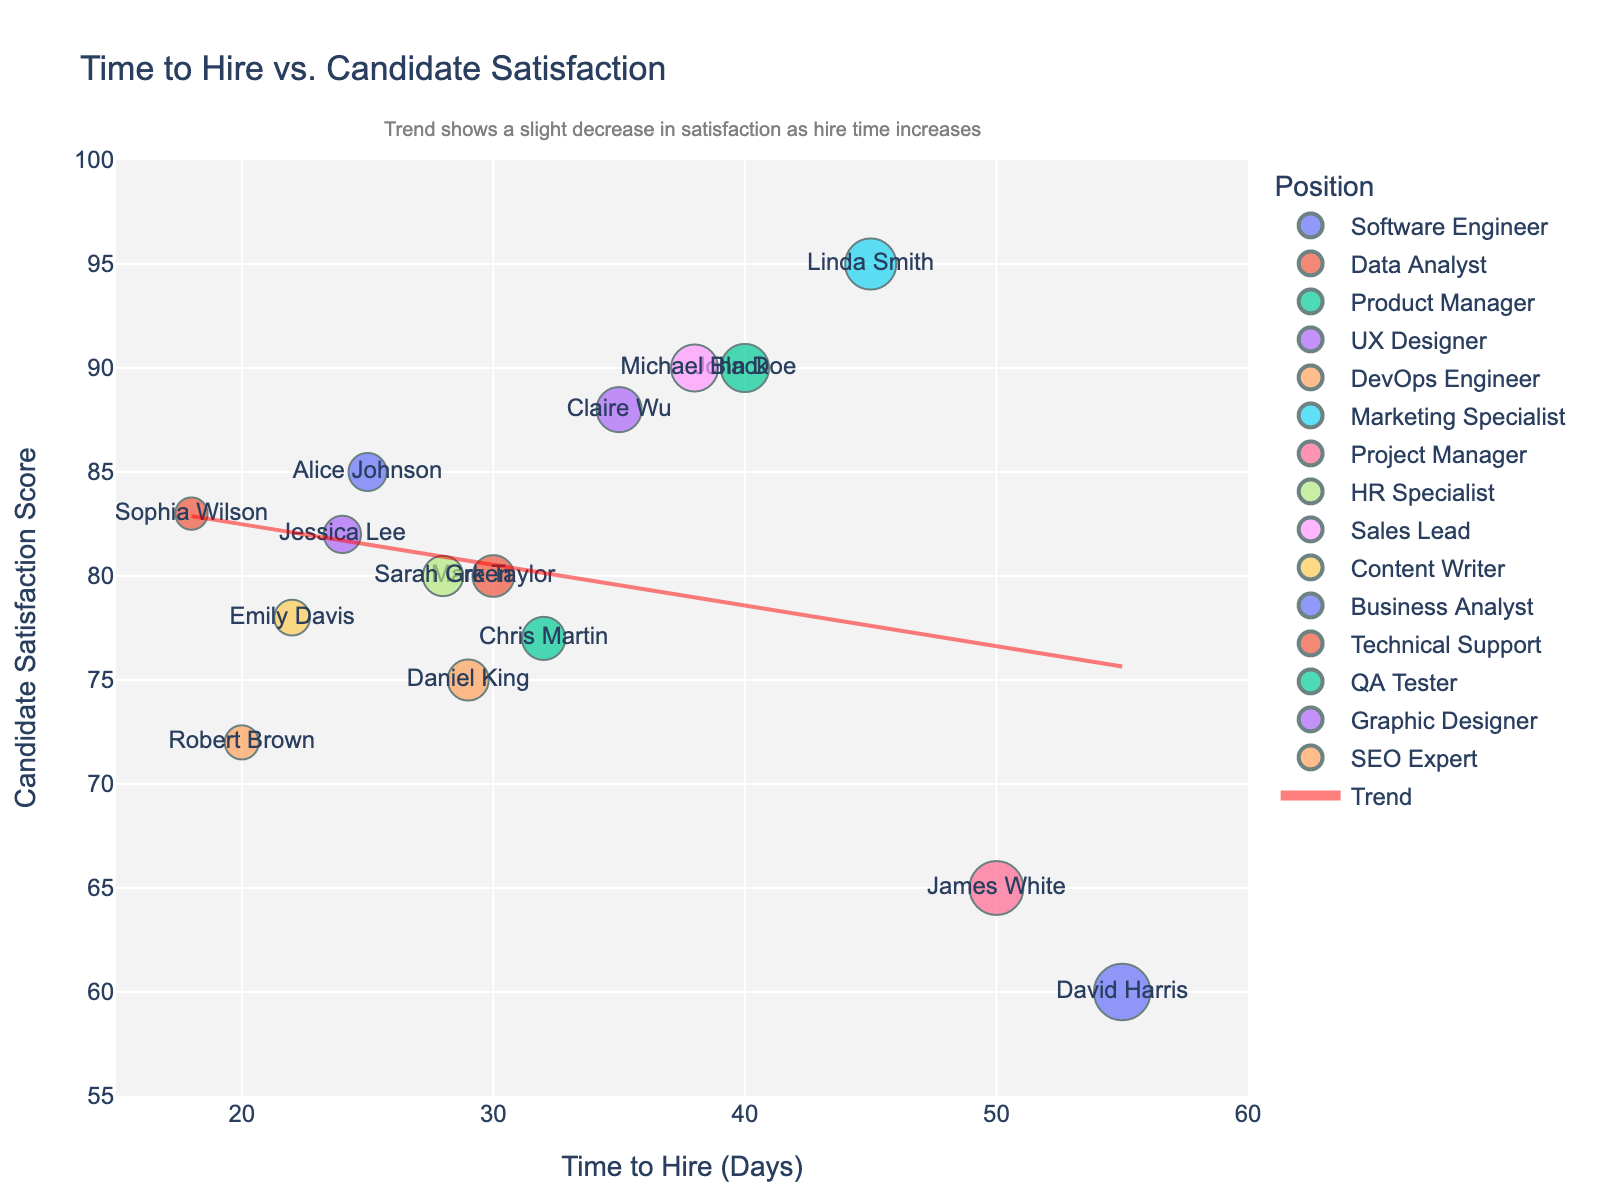How many data points are in the scatter plot? Count the number of different candidate names or dots on the scatter plot. There are 15 candidates.
Answer: 15 What are the ranges of the x-axis and y-axis? The x-axis represents 'Time to Hire (Days)' and ranges from 15 to 60 days, while the y-axis represents 'Candidate Satisfaction Score' and ranges from 55 to 100.
Answer: 15–60 for x, 55–100 for y What is the title of the scatter plot? The title is usually located at the top of the scatter plot. The title of this plot is 'Time to Hire vs. Candidate Satisfaction'.
Answer: Time to Hire vs. Candidate Satisfaction Which candidate has the highest satisfaction score and what is it? The highest data point on the y-axis represents the highest satisfaction score, which corresponds to Linda Smith. The score is 95.
Answer: Linda Smith, 95 How does the trend line behave as the time to hire increases? The trend line's direction shows the general behavior. In this plot, the trend line shows a slight decrease as time to hire increases.
Answer: Slightly decreases Which candidate was hired the fastest and what was their satisfaction score? The candidate with the lowest x-axis value is Sophia Wilson, and her satisfaction score was 83.
Answer: Sophia Wilson, 83 What is the average time to hire for all candidates? Add all the values on the x-axis and divide by the number of data points. The sum of the time to hire values is 510 (25+30+40+35+20+45+50+28+38+22+55+18+32+24+29), and there are 15 candidates, so the average is 510/15.
Answer: 34 days Which position has a satisfaction score lower than 70? Check the y-axis values lower than 70 and find the corresponding positions. James White, Project Manager, has a score of 65 and David Harris, Business Analyst, has a score of 60.
Answer: Project Manager, Business Analyst Which two positions have comparable satisfaction scores around 80? Identify the points around a y-axis value of 80 and find their corresponding positions. Sarah Green, HR Specialist (80) and Mark Taylor, Data Analyst (80).
Answer: HR Specialist, Data Analyst What's the approximate satisfaction score at a time to hire of 30 days based on the trend line? Locate 30 days on the x-axis and follow it up to where it meets the trend line, then read off the corresponding y-axis value. The score is approximately 80.
Answer: Approximately 80 